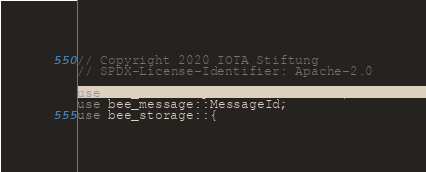Convert code to text. <code><loc_0><loc_0><loc_500><loc_500><_Rust_>// Copyright 2020 IOTA Stiftung
// SPDX-License-Identifier: Apache-2.0

use bee_common::packable::Packable;
use bee_message::MessageId;
use bee_storage::{</code> 